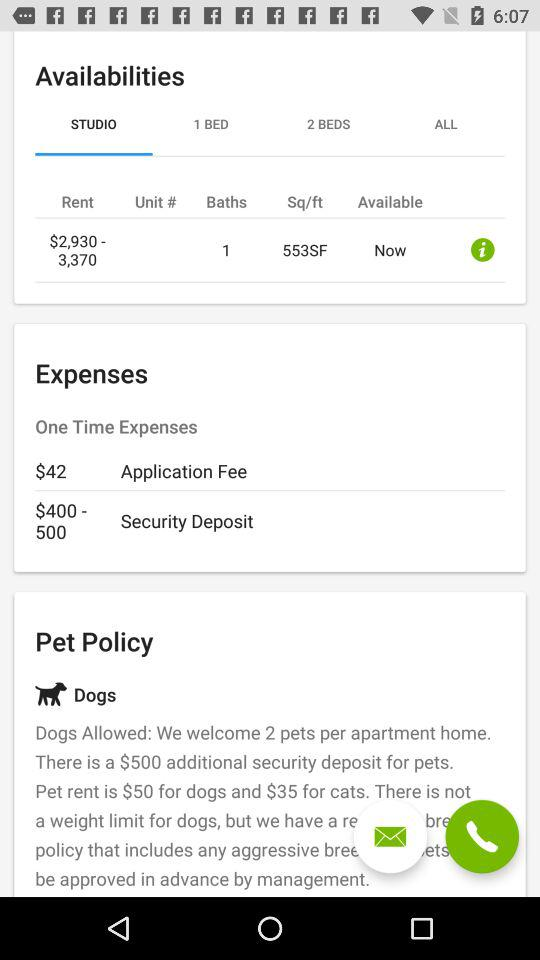What is the area in square feet? The area is 553 square feet. 